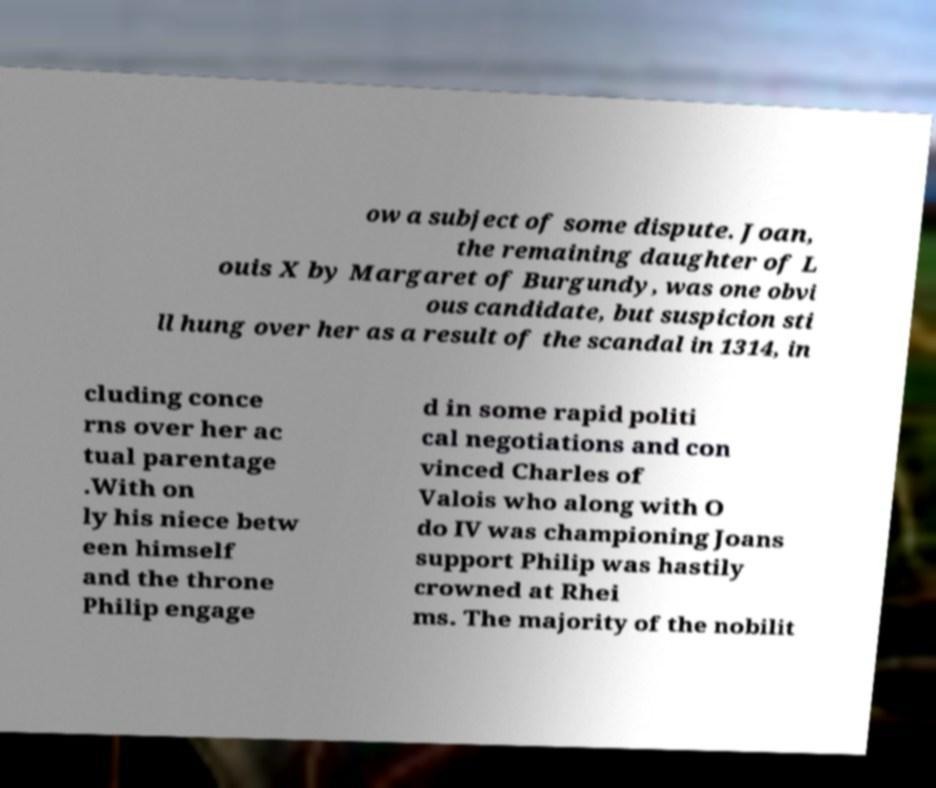For documentation purposes, I need the text within this image transcribed. Could you provide that? ow a subject of some dispute. Joan, the remaining daughter of L ouis X by Margaret of Burgundy, was one obvi ous candidate, but suspicion sti ll hung over her as a result of the scandal in 1314, in cluding conce rns over her ac tual parentage .With on ly his niece betw een himself and the throne Philip engage d in some rapid politi cal negotiations and con vinced Charles of Valois who along with O do IV was championing Joans support Philip was hastily crowned at Rhei ms. The majority of the nobilit 